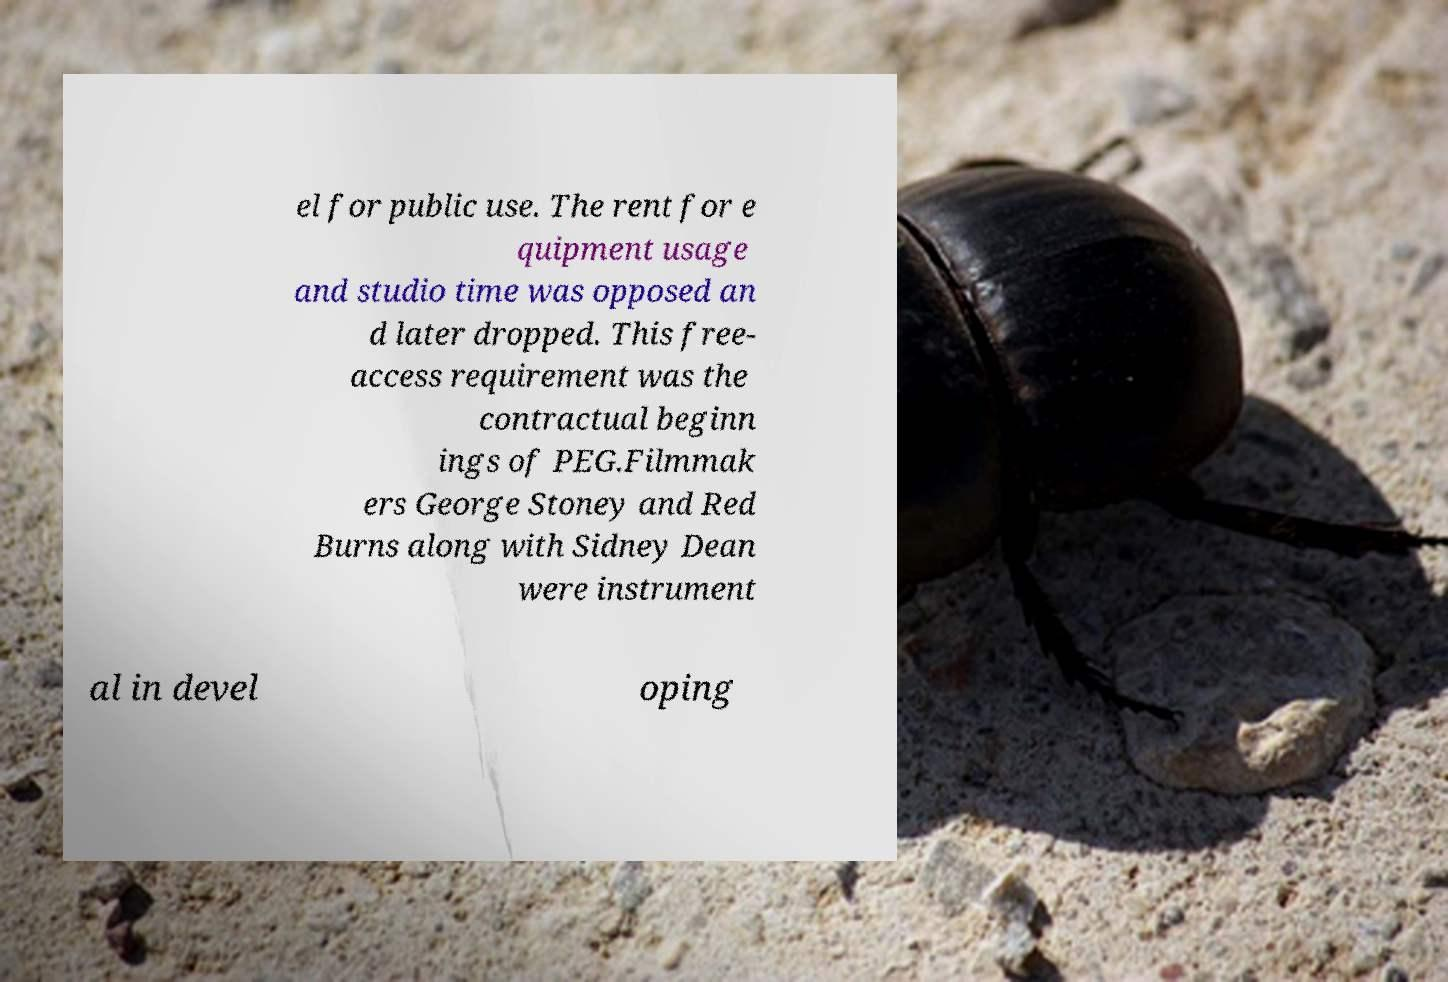Can you accurately transcribe the text from the provided image for me? el for public use. The rent for e quipment usage and studio time was opposed an d later dropped. This free- access requirement was the contractual beginn ings of PEG.Filmmak ers George Stoney and Red Burns along with Sidney Dean were instrument al in devel oping 